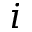<formula> <loc_0><loc_0><loc_500><loc_500>i</formula> 